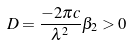<formula> <loc_0><loc_0><loc_500><loc_500>D = \frac { - 2 \pi c } { \lambda ^ { 2 } } \beta _ { 2 } > 0</formula> 